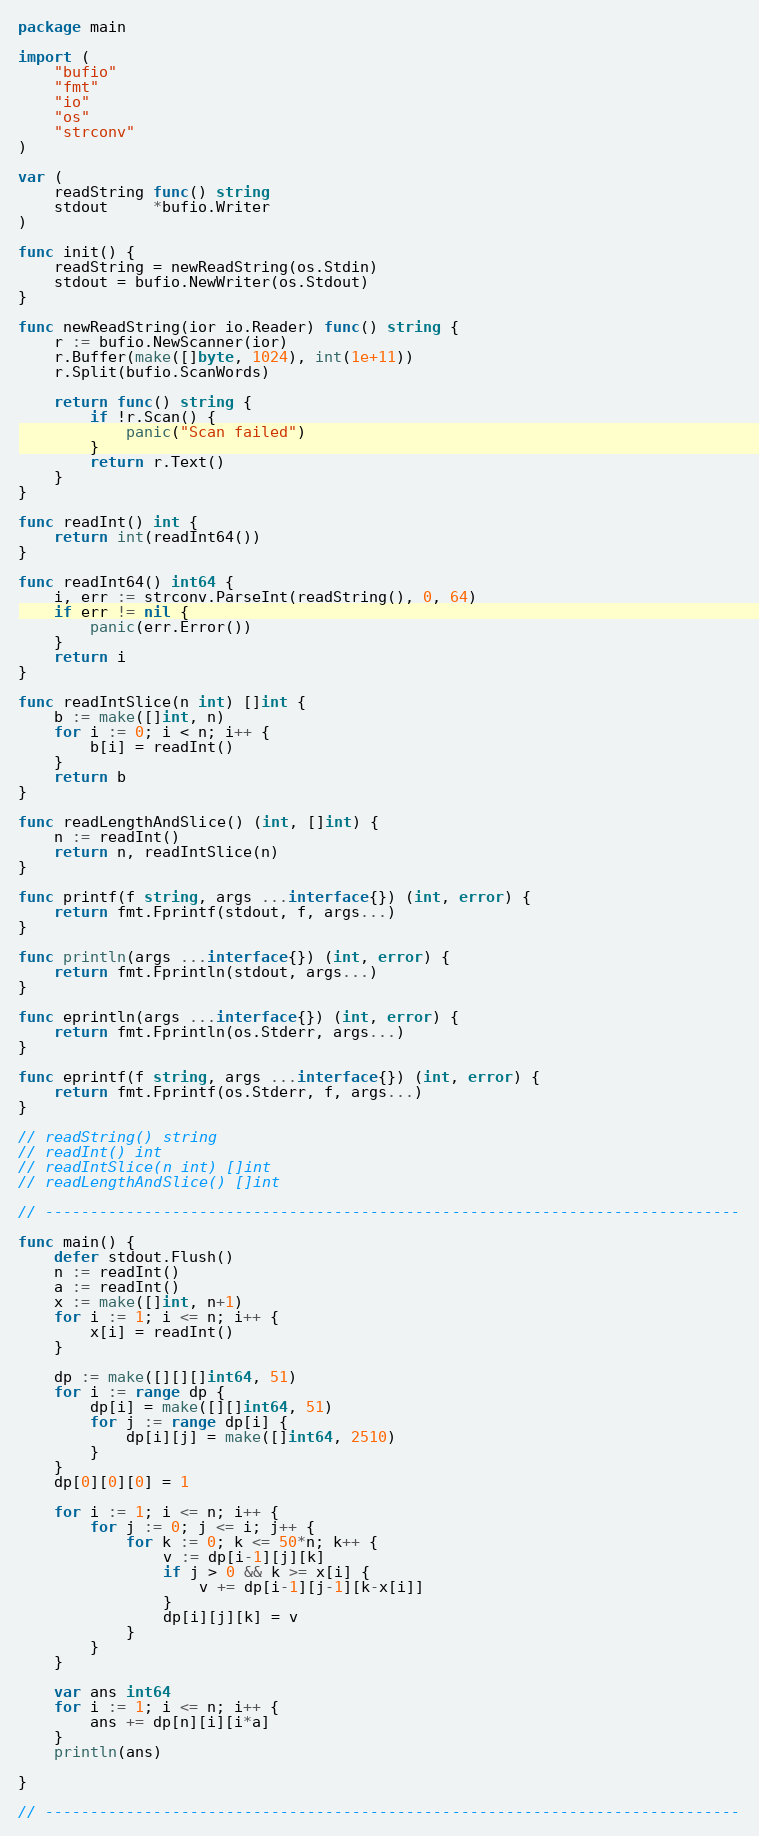Convert code to text. <code><loc_0><loc_0><loc_500><loc_500><_Go_>package main

import (
	"bufio"
	"fmt"
	"io"
	"os"
	"strconv"
)

var (
	readString func() string
	stdout     *bufio.Writer
)

func init() {
	readString = newReadString(os.Stdin)
	stdout = bufio.NewWriter(os.Stdout)
}

func newReadString(ior io.Reader) func() string {
	r := bufio.NewScanner(ior)
	r.Buffer(make([]byte, 1024), int(1e+11))
	r.Split(bufio.ScanWords)

	return func() string {
		if !r.Scan() {
			panic("Scan failed")
		}
		return r.Text()
	}
}

func readInt() int {
	return int(readInt64())
}

func readInt64() int64 {
	i, err := strconv.ParseInt(readString(), 0, 64)
	if err != nil {
		panic(err.Error())
	}
	return i
}

func readIntSlice(n int) []int {
	b := make([]int, n)
	for i := 0; i < n; i++ {
		b[i] = readInt()
	}
	return b
}

func readLengthAndSlice() (int, []int) {
	n := readInt()
	return n, readIntSlice(n)
}

func printf(f string, args ...interface{}) (int, error) {
	return fmt.Fprintf(stdout, f, args...)
}

func println(args ...interface{}) (int, error) {
	return fmt.Fprintln(stdout, args...)
}

func eprintln(args ...interface{}) (int, error) {
	return fmt.Fprintln(os.Stderr, args...)
}

func eprintf(f string, args ...interface{}) (int, error) {
	return fmt.Fprintf(os.Stderr, f, args...)
}

// readString() string
// readInt() int
// readIntSlice(n int) []int
// readLengthAndSlice() []int

// -----------------------------------------------------------------------------

func main() {
	defer stdout.Flush()
	n := readInt()
	a := readInt()
	x := make([]int, n+1)
	for i := 1; i <= n; i++ {
		x[i] = readInt()
	}

	dp := make([][][]int64, 51)
	for i := range dp {
		dp[i] = make([][]int64, 51)
		for j := range dp[i] {
			dp[i][j] = make([]int64, 2510)
		}
	}
	dp[0][0][0] = 1

	for i := 1; i <= n; i++ {
		for j := 0; j <= i; j++ {
			for k := 0; k <= 50*n; k++ {
				v := dp[i-1][j][k]
				if j > 0 && k >= x[i] {
					v += dp[i-1][j-1][k-x[i]]
				}
				dp[i][j][k] = v
			}
		}
	}

	var ans int64
	for i := 1; i <= n; i++ {
		ans += dp[n][i][i*a]
	}
	println(ans)

}

// -----------------------------------------------------------------------------
</code> 